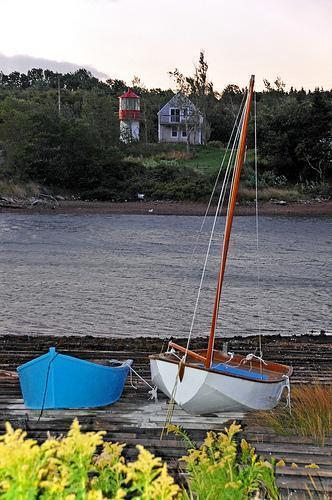How many houses are in the photo?
Give a very brief answer. 2. 